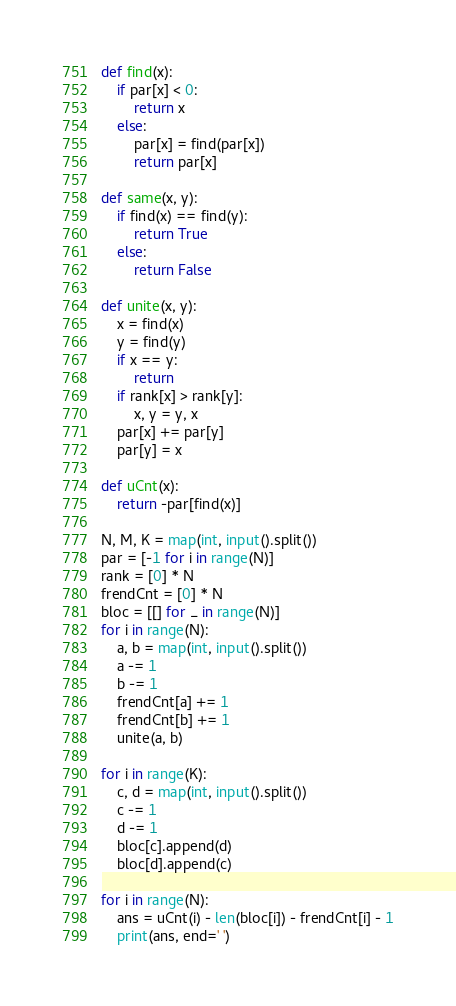Convert code to text. <code><loc_0><loc_0><loc_500><loc_500><_Python_>def find(x):
    if par[x] < 0:
        return x
    else:
        par[x] = find(par[x])
        return par[x]

def same(x, y):
    if find(x) == find(y):
        return True
    else:
        return False

def unite(x, y):
    x = find(x)
    y = find(y)
    if x == y:
        return
    if rank[x] > rank[y]:
        x, y = y, x
    par[x] += par[y]
    par[y] = x

def uCnt(x):
    return -par[find(x)]

N, M, K = map(int, input().split())
par = [-1 for i in range(N)]
rank = [0] * N
frendCnt = [0] * N
bloc = [[] for _ in range(N)]
for i in range(N):
    a, b = map(int, input().split())
    a -= 1
    b -= 1
    frendCnt[a] += 1
    frendCnt[b] += 1
    unite(a, b)

for i in range(K):
    c, d = map(int, input().split())
    c -= 1
    d -= 1
    bloc[c].append(d)
    bloc[d].append(c)

for i in range(N):
    ans = uCnt(i) - len(bloc[i]) - frendCnt[i] - 1
    print(ans, end=' ')</code> 